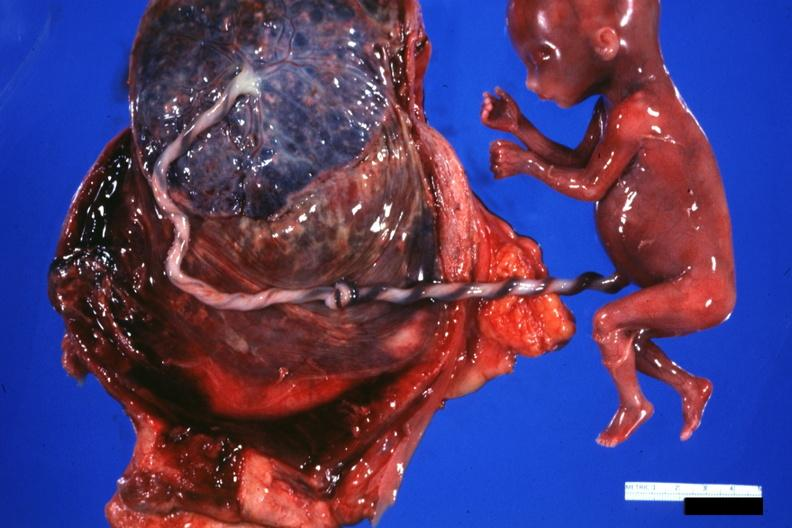s female reproductive present?
Answer the question using a single word or phrase. Yes 